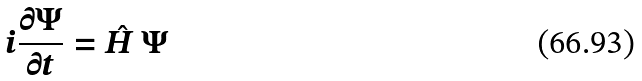Convert formula to latex. <formula><loc_0><loc_0><loc_500><loc_500>i \frac { \partial \Psi } { \partial t } = { \hat { H } } \, \Psi</formula> 